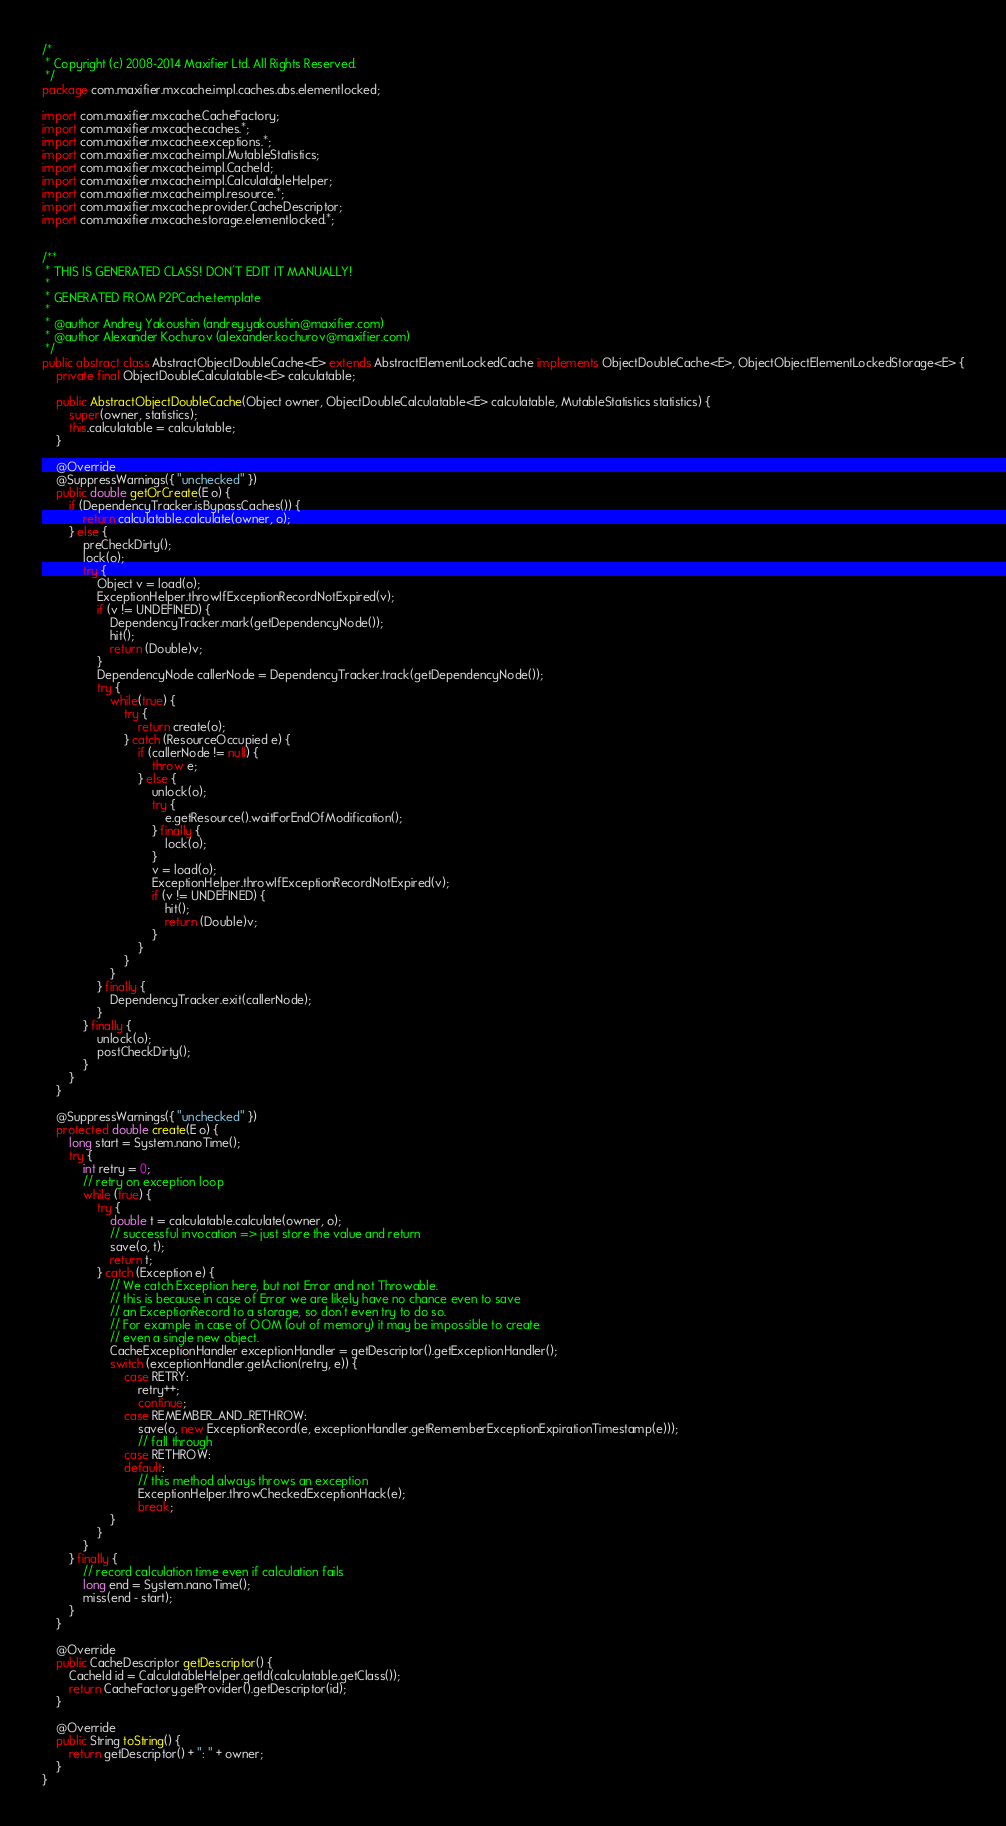Convert code to text. <code><loc_0><loc_0><loc_500><loc_500><_Java_>/*
 * Copyright (c) 2008-2014 Maxifier Ltd. All Rights Reserved.
 */
package com.maxifier.mxcache.impl.caches.abs.elementlocked;

import com.maxifier.mxcache.CacheFactory;
import com.maxifier.mxcache.caches.*;
import com.maxifier.mxcache.exceptions.*;
import com.maxifier.mxcache.impl.MutableStatistics;
import com.maxifier.mxcache.impl.CacheId;
import com.maxifier.mxcache.impl.CalculatableHelper;
import com.maxifier.mxcache.impl.resource.*;
import com.maxifier.mxcache.provider.CacheDescriptor;
import com.maxifier.mxcache.storage.elementlocked.*;


/**
 * THIS IS GENERATED CLASS! DON'T EDIT IT MANUALLY!
 *
 * GENERATED FROM P2PCache.template
 *
 * @author Andrey Yakoushin (andrey.yakoushin@maxifier.com)
 * @author Alexander Kochurov (alexander.kochurov@maxifier.com)
 */
public abstract class AbstractObjectDoubleCache<E> extends AbstractElementLockedCache implements ObjectDoubleCache<E>, ObjectObjectElementLockedStorage<E> {
    private final ObjectDoubleCalculatable<E> calculatable;

    public AbstractObjectDoubleCache(Object owner, ObjectDoubleCalculatable<E> calculatable, MutableStatistics statistics) {
        super(owner, statistics);
        this.calculatable = calculatable;
    }

    @Override
    @SuppressWarnings({ "unchecked" })
    public double getOrCreate(E o) {
        if (DependencyTracker.isBypassCaches()) {
            return calculatable.calculate(owner, o);
        } else {
            preCheckDirty();
            lock(o);
            try {
                Object v = load(o);
                ExceptionHelper.throwIfExceptionRecordNotExpired(v);
                if (v != UNDEFINED) {
                    DependencyTracker.mark(getDependencyNode());
                    hit();
                    return (Double)v;
                }
                DependencyNode callerNode = DependencyTracker.track(getDependencyNode());
                try {
                    while(true) {
                        try {
                            return create(o);
                        } catch (ResourceOccupied e) {
                            if (callerNode != null) {
                                throw e;
                            } else {
                                unlock(o);
                                try {
                                    e.getResource().waitForEndOfModification();
                                } finally {
                                    lock(o);
                                }
                                v = load(o);
                                ExceptionHelper.throwIfExceptionRecordNotExpired(v);
                                if (v != UNDEFINED) {
                                    hit();
                                    return (Double)v;
                                }
                            }
                        }
                    }
                } finally {
                    DependencyTracker.exit(callerNode);
                }
            } finally {
                unlock(o);
                postCheckDirty();
            }
        }
    }

    @SuppressWarnings({ "unchecked" })
    protected double create(E o) {
        long start = System.nanoTime();
        try {
            int retry = 0;
            // retry on exception loop
            while (true) {
                try {
                    double t = calculatable.calculate(owner, o);
                    // successful invocation => just store the value and return
                    save(o, t);
                    return t;
                } catch (Exception e) {
                    // We catch Exception here, but not Error and not Throwable.
                    // this is because in case of Error we are likely have no chance even to save
                    // an ExceptionRecord to a storage, so don't even try to do so.
                    // For example in case of OOM (out of memory) it may be impossible to create
                    // even a single new object.
                    CacheExceptionHandler exceptionHandler = getDescriptor().getExceptionHandler();
                    switch (exceptionHandler.getAction(retry, e)) {
                        case RETRY:
                            retry++;
                            continue;
                        case REMEMBER_AND_RETHROW:
                            save(o, new ExceptionRecord(e, exceptionHandler.getRememberExceptionExpirationTimestamp(e)));
                            // fall through
                        case RETHROW:
                        default:
                            // this method always throws an exception
                            ExceptionHelper.throwCheckedExceptionHack(e);
                            break;
                    }
                }
            }
        } finally {
            // record calculation time even if calculation fails
            long end = System.nanoTime();
            miss(end - start);
        }
    }

    @Override
    public CacheDescriptor getDescriptor() {
        CacheId id = CalculatableHelper.getId(calculatable.getClass());
        return CacheFactory.getProvider().getDescriptor(id);
    }

    @Override
    public String toString() {
        return getDescriptor() + ": " + owner;
    }
}</code> 